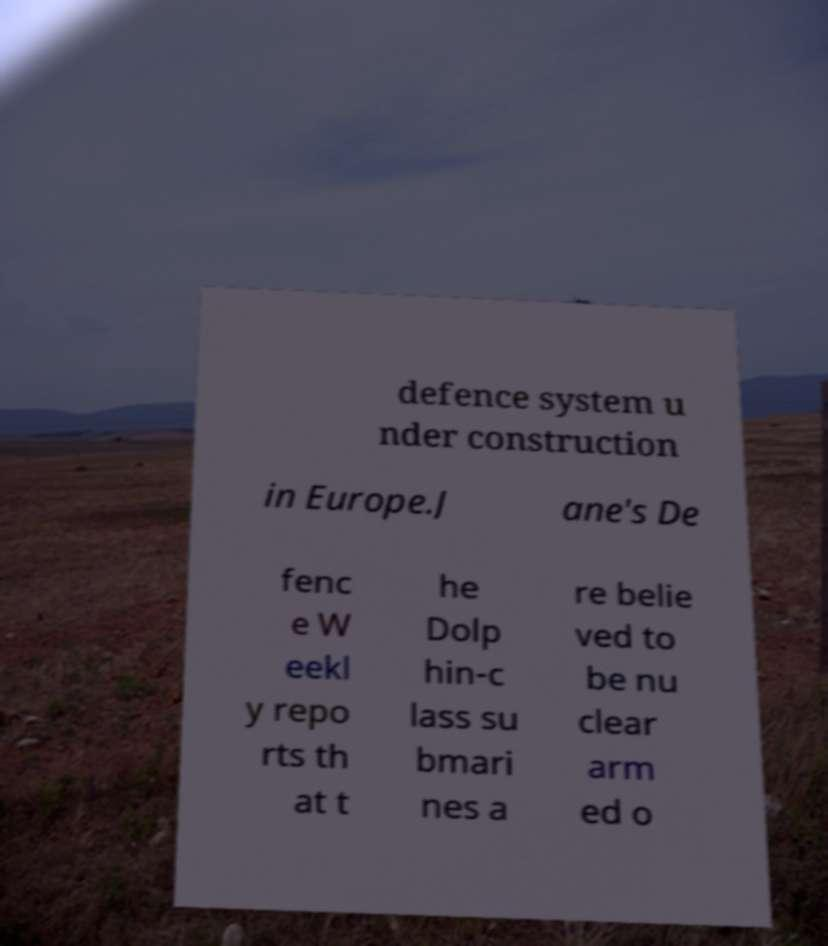I need the written content from this picture converted into text. Can you do that? defence system u nder construction in Europe.J ane's De fenc e W eekl y repo rts th at t he Dolp hin-c lass su bmari nes a re belie ved to be nu clear arm ed o 